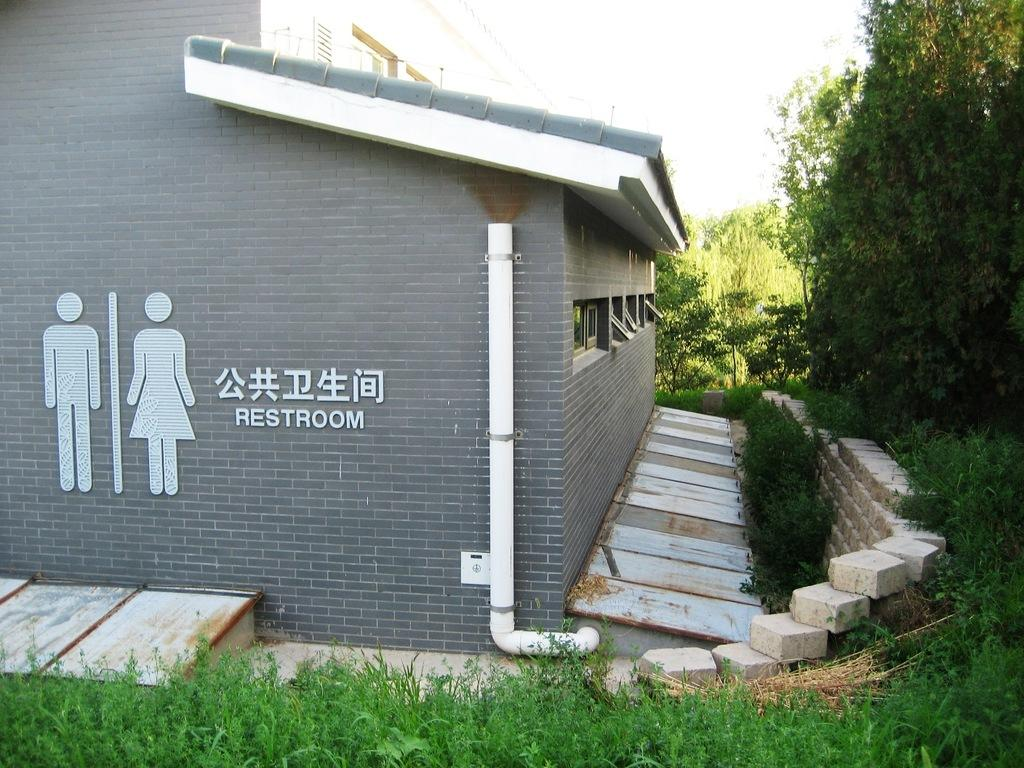What type of structure is present in the image? There is a building in the image. What can be seen on the wall of the building? There is text on the wall of the building. What type of vegetation is visible in the image? There are trees visible in the image. How would you describe the sky in the image? The sky is cloudy in the image. What type of honey is being produced by the trees in the image? There is no honey production mentioned or visible in the image; it features a building with text on the wall, trees, and a cloudy sky. 